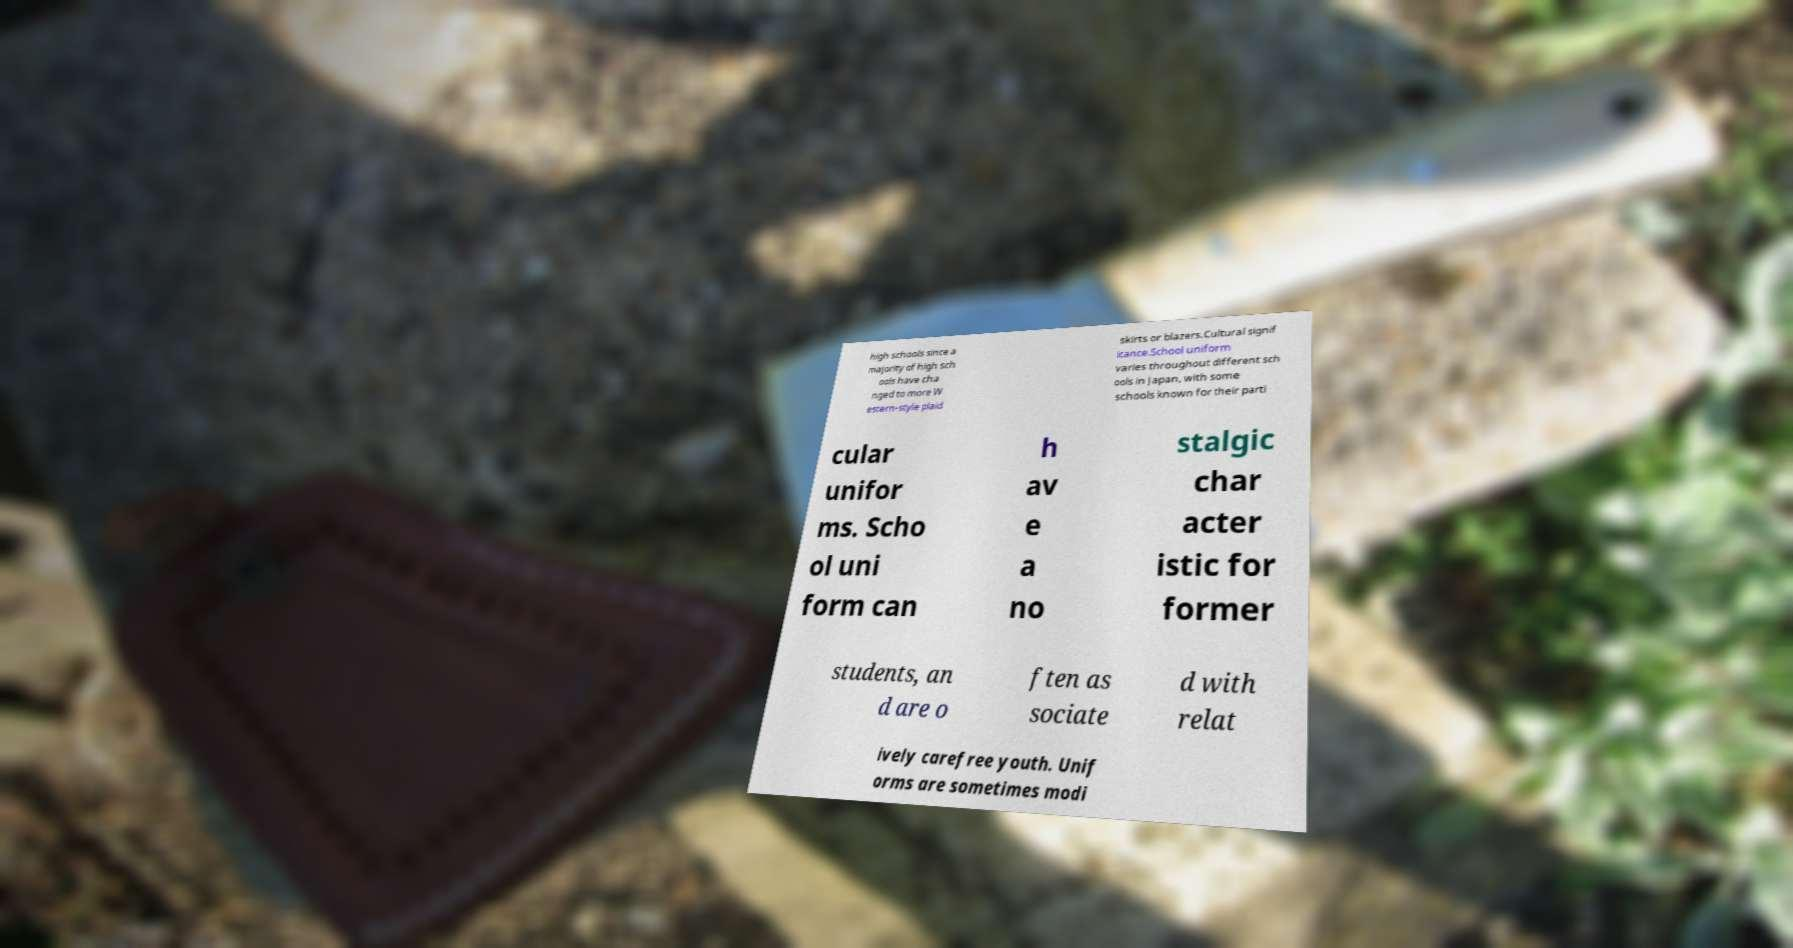Could you extract and type out the text from this image? high schools since a majority of high sch ools have cha nged to more W estern-style plaid skirts or blazers.Cultural signif icance.School uniform varies throughout different sch ools in Japan, with some schools known for their parti cular unifor ms. Scho ol uni form can h av e a no stalgic char acter istic for former students, an d are o ften as sociate d with relat ively carefree youth. Unif orms are sometimes modi 